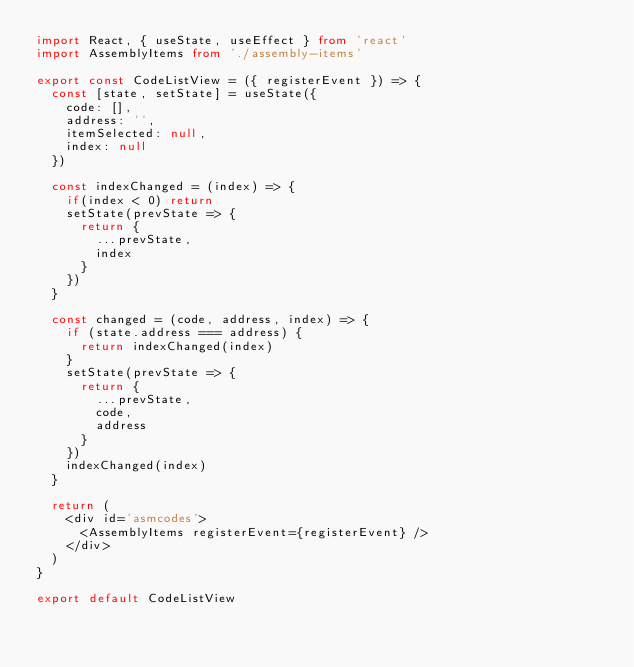<code> <loc_0><loc_0><loc_500><loc_500><_TypeScript_>import React, { useState, useEffect } from 'react'
import AssemblyItems from './assembly-items'

export const CodeListView = ({ registerEvent }) => {
  const [state, setState] = useState({
    code: [],
    address: '',
    itemSelected: null,
    index: null
  })

  const indexChanged = (index) => {
    if(index < 0) return
    setState(prevState => {
      return {
        ...prevState,
        index
      }
    })
  }

  const changed = (code, address, index) => {
    if (state.address === address) {
      return indexChanged(index)
    }
    setState(prevState => {
      return {
        ...prevState,
        code,
        address
      }
    })
    indexChanged(index)
  } 

  return (
    <div id='asmcodes'>
      <AssemblyItems registerEvent={registerEvent} />
    </div>
  )
}

export default CodeListView
</code> 